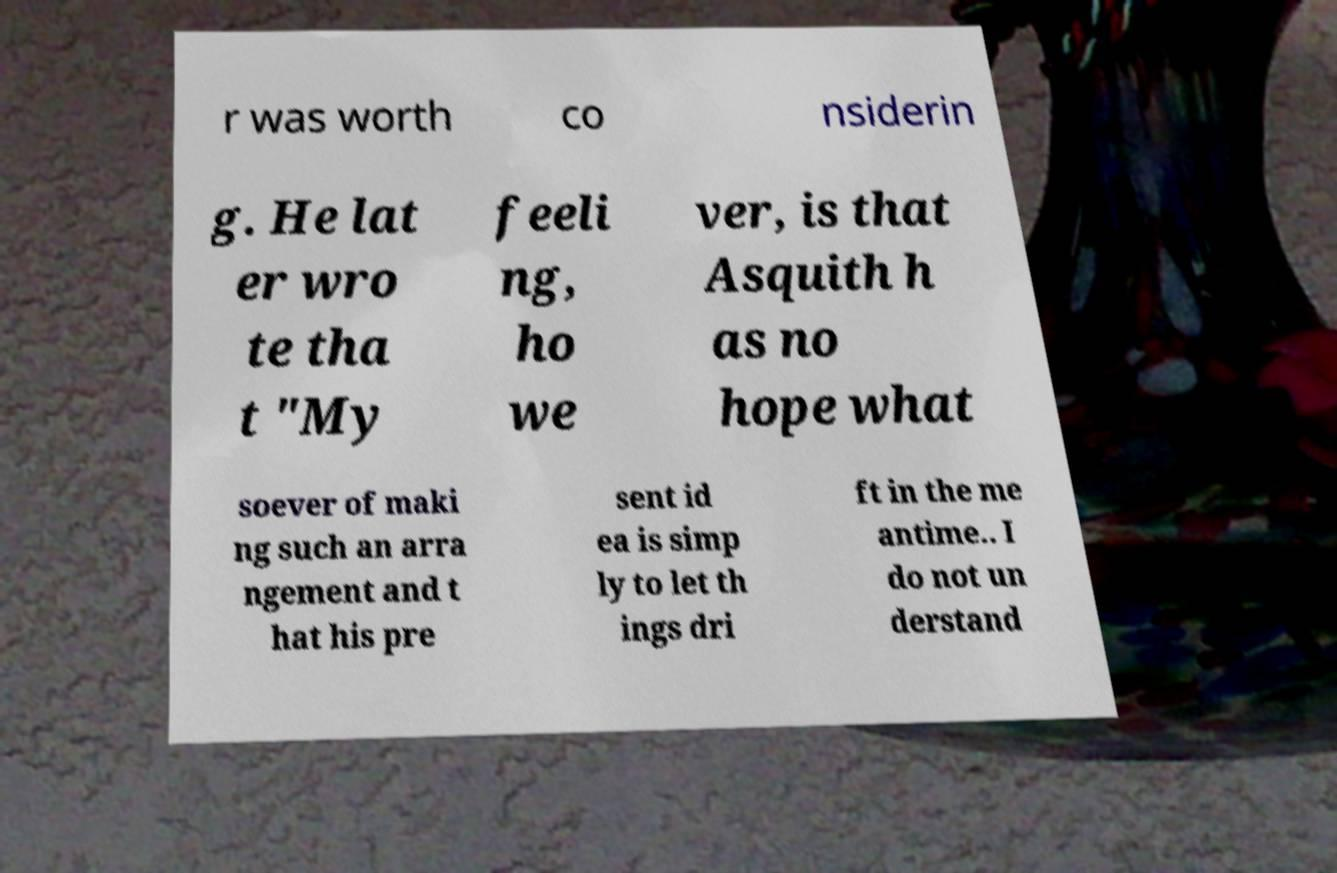I need the written content from this picture converted into text. Can you do that? r was worth co nsiderin g. He lat er wro te tha t "My feeli ng, ho we ver, is that Asquith h as no hope what soever of maki ng such an arra ngement and t hat his pre sent id ea is simp ly to let th ings dri ft in the me antime.. I do not un derstand 